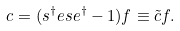Convert formula to latex. <formula><loc_0><loc_0><loc_500><loc_500>c = ( s ^ { \dagger } e s e ^ { \dagger } - 1 ) f \equiv \tilde { c } f .</formula> 